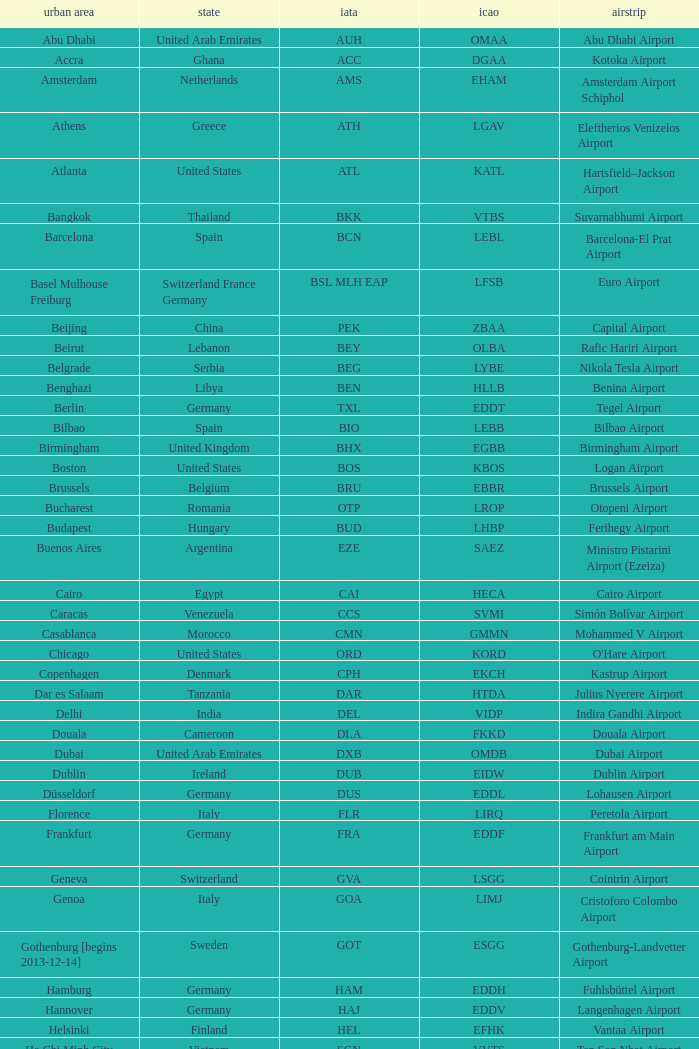What is the ICAO of Lohausen airport? EDDL. Parse the full table. {'header': ['urban area', 'state', 'iata', 'icao', 'airstrip'], 'rows': [['Abu Dhabi', 'United Arab Emirates', 'AUH', 'OMAA', 'Abu Dhabi Airport'], ['Accra', 'Ghana', 'ACC', 'DGAA', 'Kotoka Airport'], ['Amsterdam', 'Netherlands', 'AMS', 'EHAM', 'Amsterdam Airport Schiphol'], ['Athens', 'Greece', 'ATH', 'LGAV', 'Eleftherios Venizelos Airport'], ['Atlanta', 'United States', 'ATL', 'KATL', 'Hartsfield–Jackson Airport'], ['Bangkok', 'Thailand', 'BKK', 'VTBS', 'Suvarnabhumi Airport'], ['Barcelona', 'Spain', 'BCN', 'LEBL', 'Barcelona-El Prat Airport'], ['Basel Mulhouse Freiburg', 'Switzerland France Germany', 'BSL MLH EAP', 'LFSB', 'Euro Airport'], ['Beijing', 'China', 'PEK', 'ZBAA', 'Capital Airport'], ['Beirut', 'Lebanon', 'BEY', 'OLBA', 'Rafic Hariri Airport'], ['Belgrade', 'Serbia', 'BEG', 'LYBE', 'Nikola Tesla Airport'], ['Benghazi', 'Libya', 'BEN', 'HLLB', 'Benina Airport'], ['Berlin', 'Germany', 'TXL', 'EDDT', 'Tegel Airport'], ['Bilbao', 'Spain', 'BIO', 'LEBB', 'Bilbao Airport'], ['Birmingham', 'United Kingdom', 'BHX', 'EGBB', 'Birmingham Airport'], ['Boston', 'United States', 'BOS', 'KBOS', 'Logan Airport'], ['Brussels', 'Belgium', 'BRU', 'EBBR', 'Brussels Airport'], ['Bucharest', 'Romania', 'OTP', 'LROP', 'Otopeni Airport'], ['Budapest', 'Hungary', 'BUD', 'LHBP', 'Ferihegy Airport'], ['Buenos Aires', 'Argentina', 'EZE', 'SAEZ', 'Ministro Pistarini Airport (Ezeiza)'], ['Cairo', 'Egypt', 'CAI', 'HECA', 'Cairo Airport'], ['Caracas', 'Venezuela', 'CCS', 'SVMI', 'Simón Bolívar Airport'], ['Casablanca', 'Morocco', 'CMN', 'GMMN', 'Mohammed V Airport'], ['Chicago', 'United States', 'ORD', 'KORD', "O'Hare Airport"], ['Copenhagen', 'Denmark', 'CPH', 'EKCH', 'Kastrup Airport'], ['Dar es Salaam', 'Tanzania', 'DAR', 'HTDA', 'Julius Nyerere Airport'], ['Delhi', 'India', 'DEL', 'VIDP', 'Indira Gandhi Airport'], ['Douala', 'Cameroon', 'DLA', 'FKKD', 'Douala Airport'], ['Dubai', 'United Arab Emirates', 'DXB', 'OMDB', 'Dubai Airport'], ['Dublin', 'Ireland', 'DUB', 'EIDW', 'Dublin Airport'], ['Düsseldorf', 'Germany', 'DUS', 'EDDL', 'Lohausen Airport'], ['Florence', 'Italy', 'FLR', 'LIRQ', 'Peretola Airport'], ['Frankfurt', 'Germany', 'FRA', 'EDDF', 'Frankfurt am Main Airport'], ['Geneva', 'Switzerland', 'GVA', 'LSGG', 'Cointrin Airport'], ['Genoa', 'Italy', 'GOA', 'LIMJ', 'Cristoforo Colombo Airport'], ['Gothenburg [begins 2013-12-14]', 'Sweden', 'GOT', 'ESGG', 'Gothenburg-Landvetter Airport'], ['Hamburg', 'Germany', 'HAM', 'EDDH', 'Fuhlsbüttel Airport'], ['Hannover', 'Germany', 'HAJ', 'EDDV', 'Langenhagen Airport'], ['Helsinki', 'Finland', 'HEL', 'EFHK', 'Vantaa Airport'], ['Ho Chi Minh City', 'Vietnam', 'SGN', 'VVTS', 'Tan Son Nhat Airport'], ['Hong Kong', 'Hong Kong', 'HKG', 'VHHH', 'Chek Lap Kok Airport'], ['Istanbul', 'Turkey', 'IST', 'LTBA', 'Atatürk Airport'], ['Jakarta', 'Indonesia', 'CGK', 'WIII', 'Soekarno–Hatta Airport'], ['Jeddah', 'Saudi Arabia', 'JED', 'OEJN', 'King Abdulaziz Airport'], ['Johannesburg', 'South Africa', 'JNB', 'FAJS', 'OR Tambo Airport'], ['Karachi', 'Pakistan', 'KHI', 'OPKC', 'Jinnah Airport'], ['Kiev', 'Ukraine', 'KBP', 'UKBB', 'Boryspil International Airport'], ['Lagos', 'Nigeria', 'LOS', 'DNMM', 'Murtala Muhammed Airport'], ['Libreville', 'Gabon', 'LBV', 'FOOL', "Leon M'ba Airport"], ['Lisbon', 'Portugal', 'LIS', 'LPPT', 'Portela Airport'], ['London', 'United Kingdom', 'LCY', 'EGLC', 'City Airport'], ['London [begins 2013-12-14]', 'United Kingdom', 'LGW', 'EGKK', 'Gatwick Airport'], ['London', 'United Kingdom', 'LHR', 'EGLL', 'Heathrow Airport'], ['Los Angeles', 'United States', 'LAX', 'KLAX', 'Los Angeles International Airport'], ['Lugano', 'Switzerland', 'LUG', 'LSZA', 'Agno Airport'], ['Luxembourg City', 'Luxembourg', 'LUX', 'ELLX', 'Findel Airport'], ['Lyon', 'France', 'LYS', 'LFLL', 'Saint-Exupéry Airport'], ['Madrid', 'Spain', 'MAD', 'LEMD', 'Madrid-Barajas Airport'], ['Malabo', 'Equatorial Guinea', 'SSG', 'FGSL', 'Saint Isabel Airport'], ['Malaga', 'Spain', 'AGP', 'LEMG', 'Málaga-Costa del Sol Airport'], ['Manchester', 'United Kingdom', 'MAN', 'EGCC', 'Ringway Airport'], ['Manila', 'Philippines', 'MNL', 'RPLL', 'Ninoy Aquino Airport'], ['Marrakech [begins 2013-11-01]', 'Morocco', 'RAK', 'GMMX', 'Menara Airport'], ['Miami', 'United States', 'MIA', 'KMIA', 'Miami Airport'], ['Milan', 'Italy', 'MXP', 'LIMC', 'Malpensa Airport'], ['Minneapolis', 'United States', 'MSP', 'KMSP', 'Minneapolis Airport'], ['Montreal', 'Canada', 'YUL', 'CYUL', 'Pierre Elliott Trudeau Airport'], ['Moscow', 'Russia', 'DME', 'UUDD', 'Domodedovo Airport'], ['Mumbai', 'India', 'BOM', 'VABB', 'Chhatrapati Shivaji Airport'], ['Munich', 'Germany', 'MUC', 'EDDM', 'Franz Josef Strauss Airport'], ['Muscat', 'Oman', 'MCT', 'OOMS', 'Seeb Airport'], ['Nairobi', 'Kenya', 'NBO', 'HKJK', 'Jomo Kenyatta Airport'], ['Newark', 'United States', 'EWR', 'KEWR', 'Liberty Airport'], ['New York City', 'United States', 'JFK', 'KJFK', 'John F Kennedy Airport'], ['Nice', 'France', 'NCE', 'LFMN', "Côte d'Azur Airport"], ['Nuremberg', 'Germany', 'NUE', 'EDDN', 'Nuremberg Airport'], ['Oslo', 'Norway', 'OSL', 'ENGM', 'Gardermoen Airport'], ['Palma de Mallorca', 'Spain', 'PMI', 'LFPA', 'Palma de Mallorca Airport'], ['Paris', 'France', 'CDG', 'LFPG', 'Charles de Gaulle Airport'], ['Porto', 'Portugal', 'OPO', 'LPPR', 'Francisco de Sa Carneiro Airport'], ['Prague', 'Czech Republic', 'PRG', 'LKPR', 'Ruzyně Airport'], ['Riga', 'Latvia', 'RIX', 'EVRA', 'Riga Airport'], ['Rio de Janeiro [resumes 2014-7-14]', 'Brazil', 'GIG', 'SBGL', 'Galeão Airport'], ['Riyadh', 'Saudi Arabia', 'RUH', 'OERK', 'King Khalid Airport'], ['Rome', 'Italy', 'FCO', 'LIRF', 'Leonardo da Vinci Airport'], ['Saint Petersburg', 'Russia', 'LED', 'ULLI', 'Pulkovo Airport'], ['San Francisco', 'United States', 'SFO', 'KSFO', 'San Francisco Airport'], ['Santiago', 'Chile', 'SCL', 'SCEL', 'Comodoro Arturo Benitez Airport'], ['São Paulo', 'Brazil', 'GRU', 'SBGR', 'Guarulhos Airport'], ['Sarajevo', 'Bosnia and Herzegovina', 'SJJ', 'LQSA', 'Butmir Airport'], ['Seattle', 'United States', 'SEA', 'KSEA', 'Sea-Tac Airport'], ['Shanghai', 'China', 'PVG', 'ZSPD', 'Pudong Airport'], ['Singapore', 'Singapore', 'SIN', 'WSSS', 'Changi Airport'], ['Skopje', 'Republic of Macedonia', 'SKP', 'LWSK', 'Alexander the Great Airport'], ['Sofia', 'Bulgaria', 'SOF', 'LBSF', 'Vrazhdebna Airport'], ['Stockholm', 'Sweden', 'ARN', 'ESSA', 'Arlanda Airport'], ['Stuttgart', 'Germany', 'STR', 'EDDS', 'Echterdingen Airport'], ['Taipei', 'Taiwan', 'TPE', 'RCTP', 'Taoyuan Airport'], ['Tehran', 'Iran', 'IKA', 'OIIE', 'Imam Khomeini Airport'], ['Tel Aviv', 'Israel', 'TLV', 'LLBG', 'Ben Gurion Airport'], ['Thessaloniki', 'Greece', 'SKG', 'LGTS', 'Macedonia Airport'], ['Tirana', 'Albania', 'TIA', 'LATI', 'Nënë Tereza Airport'], ['Tokyo', 'Japan', 'NRT', 'RJAA', 'Narita Airport'], ['Toronto', 'Canada', 'YYZ', 'CYYZ', 'Pearson Airport'], ['Tripoli', 'Libya', 'TIP', 'HLLT', 'Tripoli Airport'], ['Tunis', 'Tunisia', 'TUN', 'DTTA', 'Carthage Airport'], ['Turin', 'Italy', 'TRN', 'LIMF', 'Sandro Pertini Airport'], ['Valencia', 'Spain', 'VLC', 'LEVC', 'Valencia Airport'], ['Venice', 'Italy', 'VCE', 'LIPZ', 'Marco Polo Airport'], ['Vienna', 'Austria', 'VIE', 'LOWW', 'Schwechat Airport'], ['Warsaw', 'Poland', 'WAW', 'EPWA', 'Frederic Chopin Airport'], ['Washington DC', 'United States', 'IAD', 'KIAD', 'Dulles Airport'], ['Yaounde', 'Cameroon', 'NSI', 'FKYS', 'Yaounde Nsimalen Airport'], ['Yerevan', 'Armenia', 'EVN', 'UDYZ', 'Zvartnots Airport'], ['Zurich', 'Switzerland', 'ZRH', 'LSZH', 'Zurich Airport']]} 